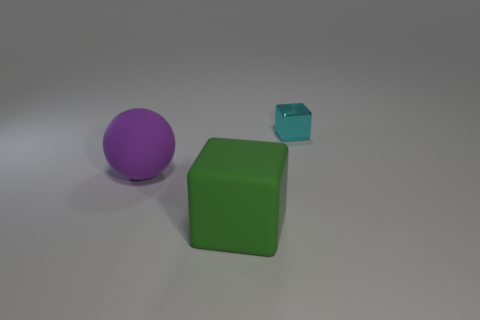Add 2 rubber cubes. How many objects exist? 5 Subtract all green blocks. How many blocks are left? 1 Subtract all spheres. How many objects are left? 2 Subtract all tiny cyan objects. Subtract all tiny shiny things. How many objects are left? 1 Add 3 purple matte spheres. How many purple matte spheres are left? 4 Add 1 green things. How many green things exist? 2 Subtract 0 brown spheres. How many objects are left? 3 Subtract 1 balls. How many balls are left? 0 Subtract all gray spheres. Subtract all green blocks. How many spheres are left? 1 Subtract all cyan spheres. How many green cubes are left? 1 